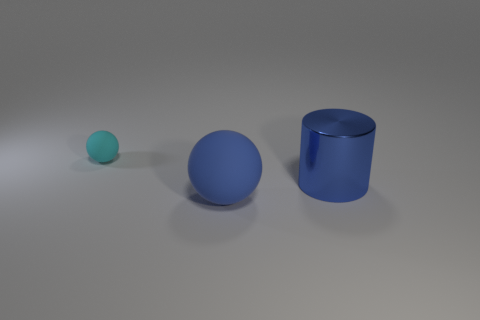There is a blue matte object that is the same shape as the cyan rubber object; what size is it?
Your answer should be compact. Large. There is a cyan matte ball; what number of cylinders are behind it?
Make the answer very short. 0. What is the object that is both to the left of the big blue shiny thing and in front of the tiny cyan matte object made of?
Ensure brevity in your answer.  Rubber. How many tiny objects are either blue balls or red matte cubes?
Your response must be concise. 0. The cyan thing has what size?
Keep it short and to the point. Small. The large metallic thing is what shape?
Ensure brevity in your answer.  Cylinder. Are there any other things that are the same shape as the cyan thing?
Provide a succinct answer. Yes. Are there fewer cyan objects on the left side of the big matte sphere than big green metallic objects?
Your response must be concise. No. Is the color of the rubber sphere in front of the cyan ball the same as the metal object?
Make the answer very short. Yes. How many metallic objects are either blue spheres or big brown things?
Provide a short and direct response. 0. 